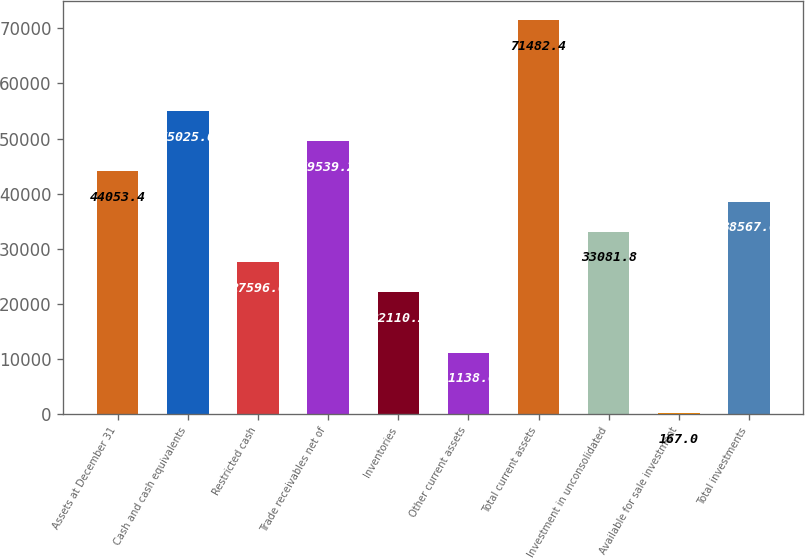Convert chart. <chart><loc_0><loc_0><loc_500><loc_500><bar_chart><fcel>Assets at December 31<fcel>Cash and cash equivalents<fcel>Restricted cash<fcel>Trade receivables net of<fcel>Inventories<fcel>Other current assets<fcel>Total current assets<fcel>Investment in unconsolidated<fcel>Available for sale investment<fcel>Total investments<nl><fcel>44053.4<fcel>55025<fcel>27596<fcel>49539.2<fcel>22110.2<fcel>11138.6<fcel>71482.4<fcel>33081.8<fcel>167<fcel>38567.6<nl></chart> 